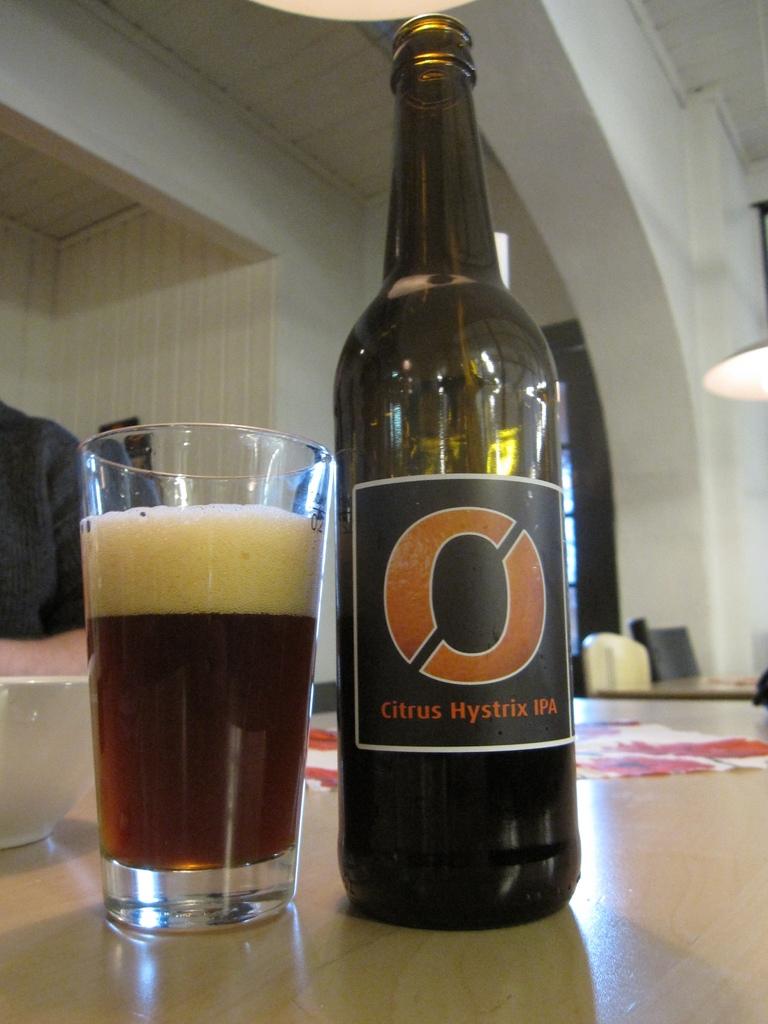What type of fruit is the first word?
Keep it short and to the point. Citrus. 